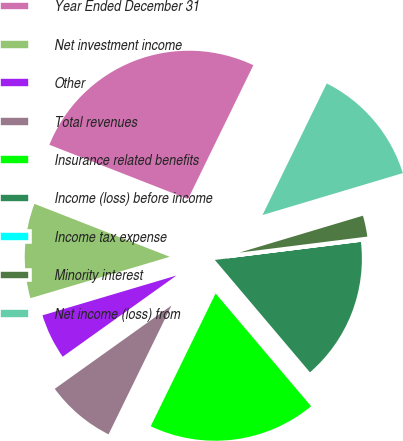<chart> <loc_0><loc_0><loc_500><loc_500><pie_chart><fcel>Year Ended December 31<fcel>Net investment income<fcel>Other<fcel>Total revenues<fcel>Insurance related benefits<fcel>Income (loss) before income<fcel>Income tax expense<fcel>Minority interest<fcel>Net income (loss) from<nl><fcel>26.29%<fcel>10.53%<fcel>5.27%<fcel>7.9%<fcel>18.41%<fcel>15.78%<fcel>0.02%<fcel>2.64%<fcel>13.15%<nl></chart> 